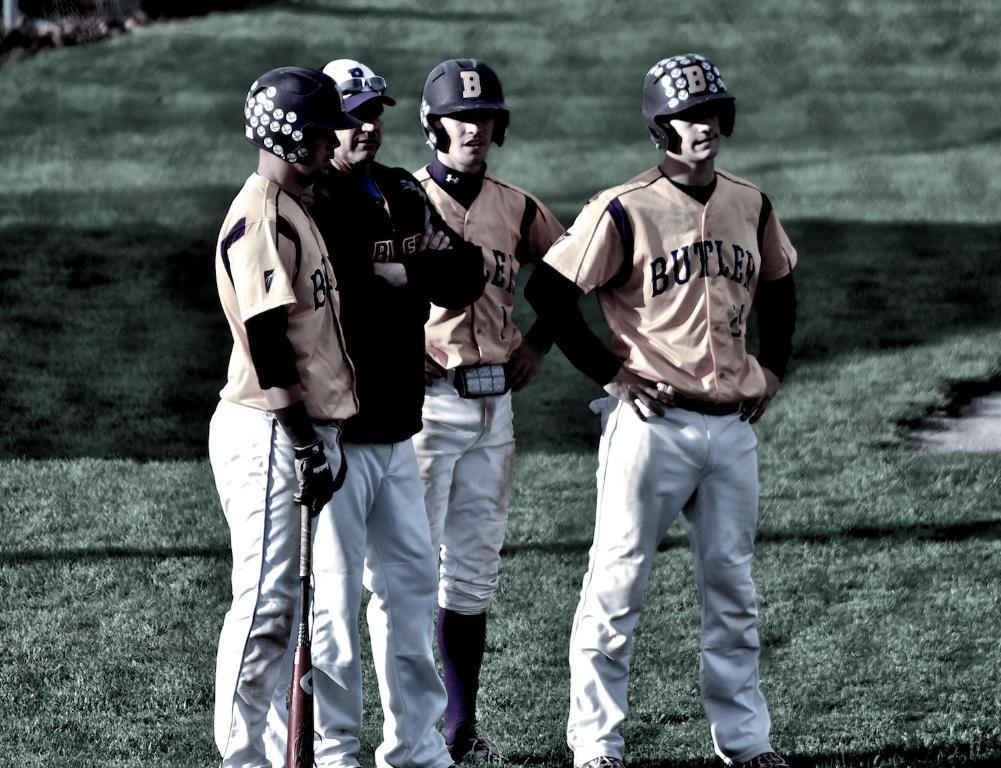Please provide a concise description of this image. In this image, we can see persons standing and wearing clothes. There is a person on the left side of the image holding a bat with his hand. 